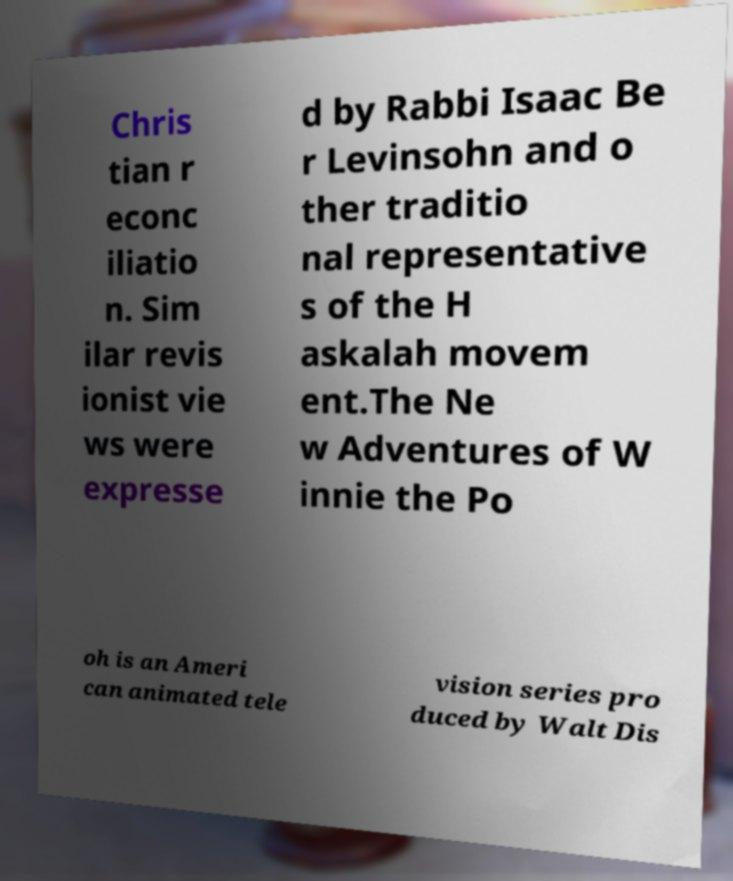There's text embedded in this image that I need extracted. Can you transcribe it verbatim? Chris tian r econc iliatio n. Sim ilar revis ionist vie ws were expresse d by Rabbi Isaac Be r Levinsohn and o ther traditio nal representative s of the H askalah movem ent.The Ne w Adventures of W innie the Po oh is an Ameri can animated tele vision series pro duced by Walt Dis 